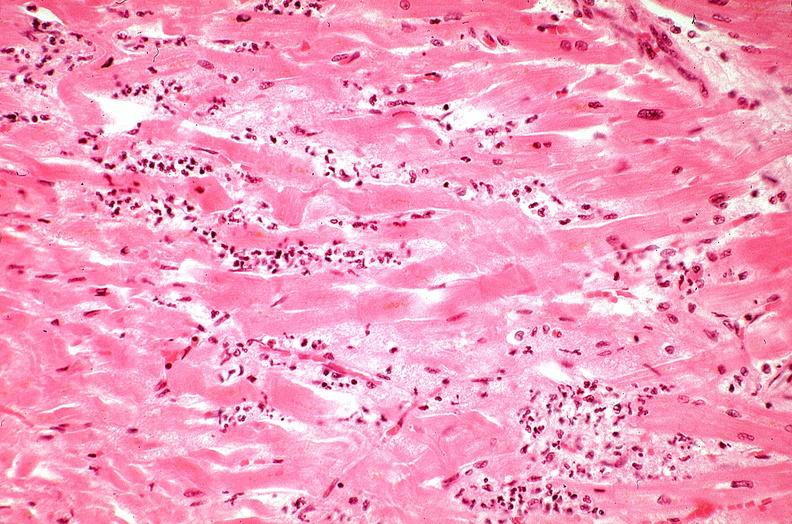where is this from?
Answer the question using a single word or phrase. Heart 